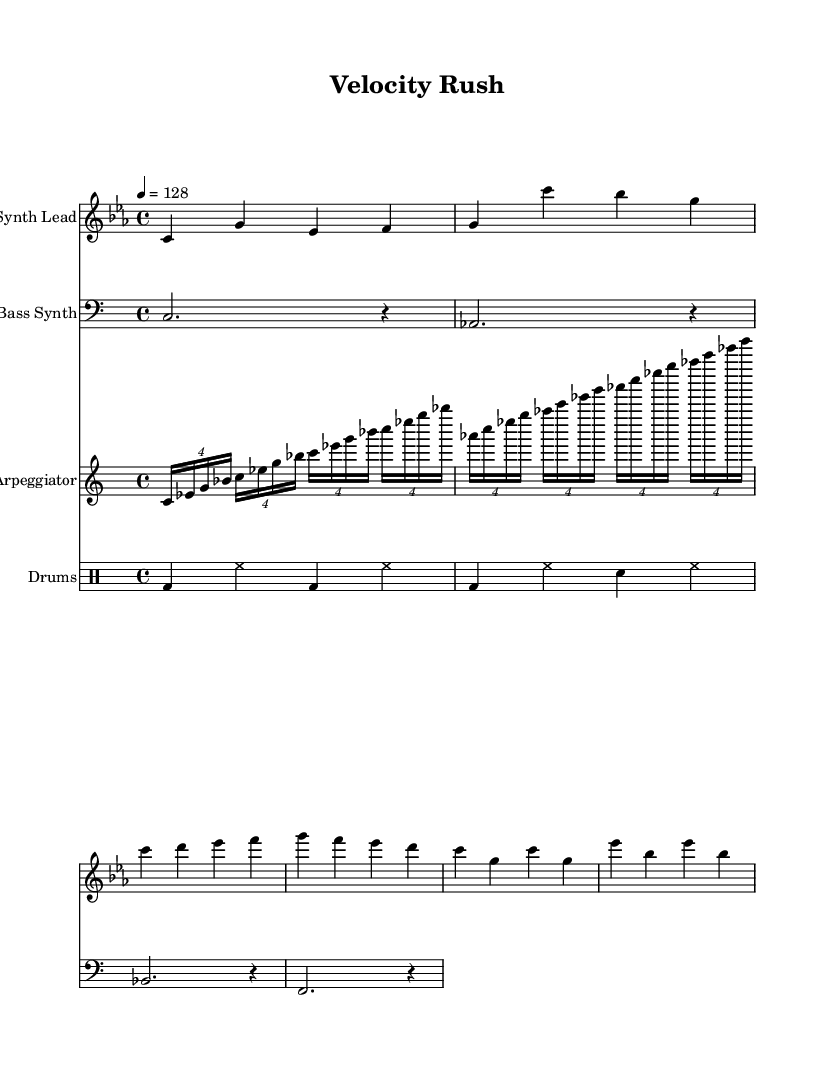What is the key signature of this music? The key signature is C minor, indicated by three flats in the music staff.
Answer: C minor What is the time signature of this piece? The time signature is 4/4, which can be seen at the beginning of the score.
Answer: 4/4 What is the tempo marking of this music? The tempo is marked as 128 beats per minute, indicated by the tempo text at the beginning of the staff.
Answer: 128 How many measures does the synth lead section have? The synth lead section consists of eight measures, as counted visually from the music notes.
Answer: Eight What type of drum pattern is used in this score? The drum pattern consists of bass drums, hi-hats, and snare drums, which follow a typical house music rhythm structure.
Answer: Bass drum and snare Which instrument plays the arpeggiated pattern? The arpeggiator part is indicated on the treble clef staff and plays harmonic notes in rapid succession.
Answer: Arpeggiator What is the rhythmic subdivision used in the arpeggiator part? The arpeggiator uses sixteenth notes grouped in tuplets, creating a fast, flowing rhythm characteristic of progressive house music.
Answer: Sixteenth notes 